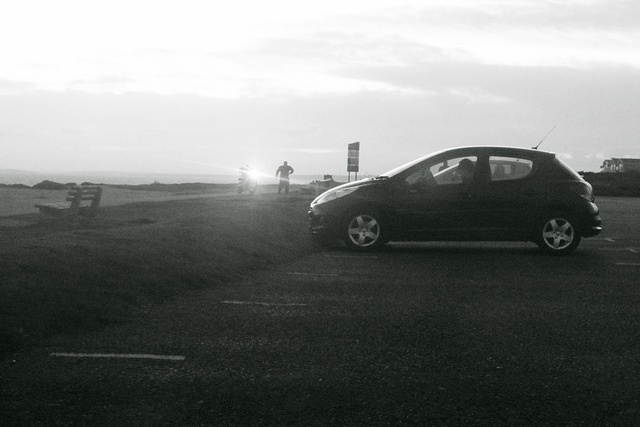Describe the objects in this image and their specific colors. I can see car in white, black, gray, darkgray, and lightgray tones, bench in white, gray, and black tones, people in white, darkgray, gray, and lightgray tones, people in white, gray, and black tones, and bench in white, gray, darkgray, and lightgray tones in this image. 